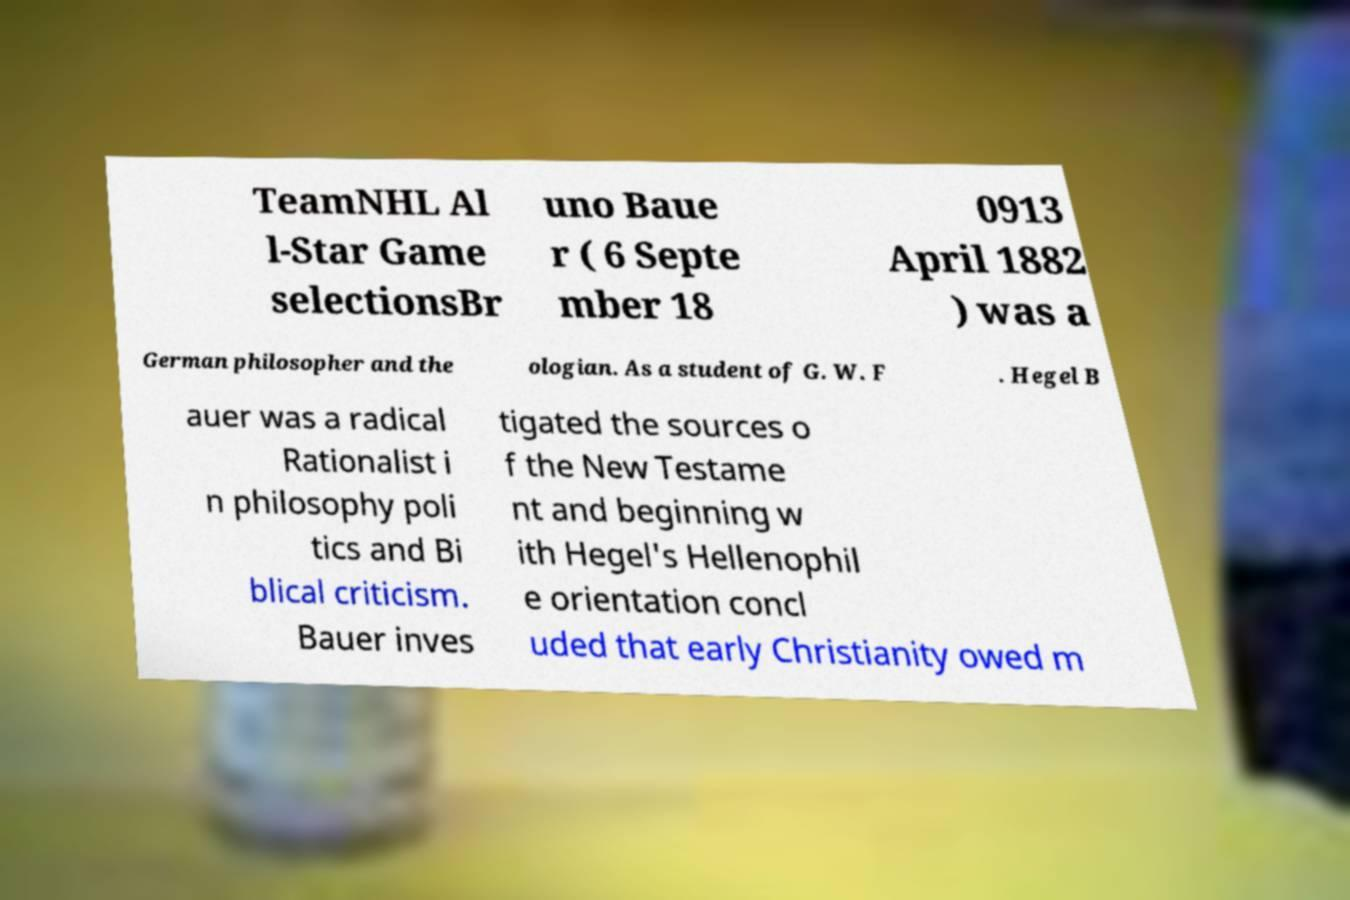Could you assist in decoding the text presented in this image and type it out clearly? TeamNHL Al l-Star Game selectionsBr uno Baue r ( 6 Septe mber 18 0913 April 1882 ) was a German philosopher and the ologian. As a student of G. W. F . Hegel B auer was a radical Rationalist i n philosophy poli tics and Bi blical criticism. Bauer inves tigated the sources o f the New Testame nt and beginning w ith Hegel's Hellenophil e orientation concl uded that early Christianity owed m 